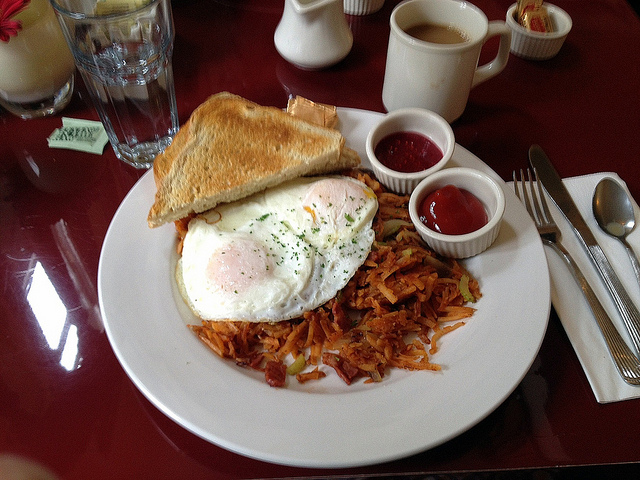Can you suggest a beverage that would pair well with this breakfast? To enhance your enjoyment of this delicious breakfast of eggs, toast, and hash browns, a freshly brewed cup of aromatic coffee would be perfect. The rich and robust flavor of the coffee will complement the savory elements of the meal. If you prefer a non-caffeinated beverage, consider a glass of refreshing cold orange juice, providing a delightful contrast with its sweetness and acidity. Additionally, a mixed berry smoothie not only adds a refreshing touch but also brings a nutritious and colorful aspect to your breakfast. 